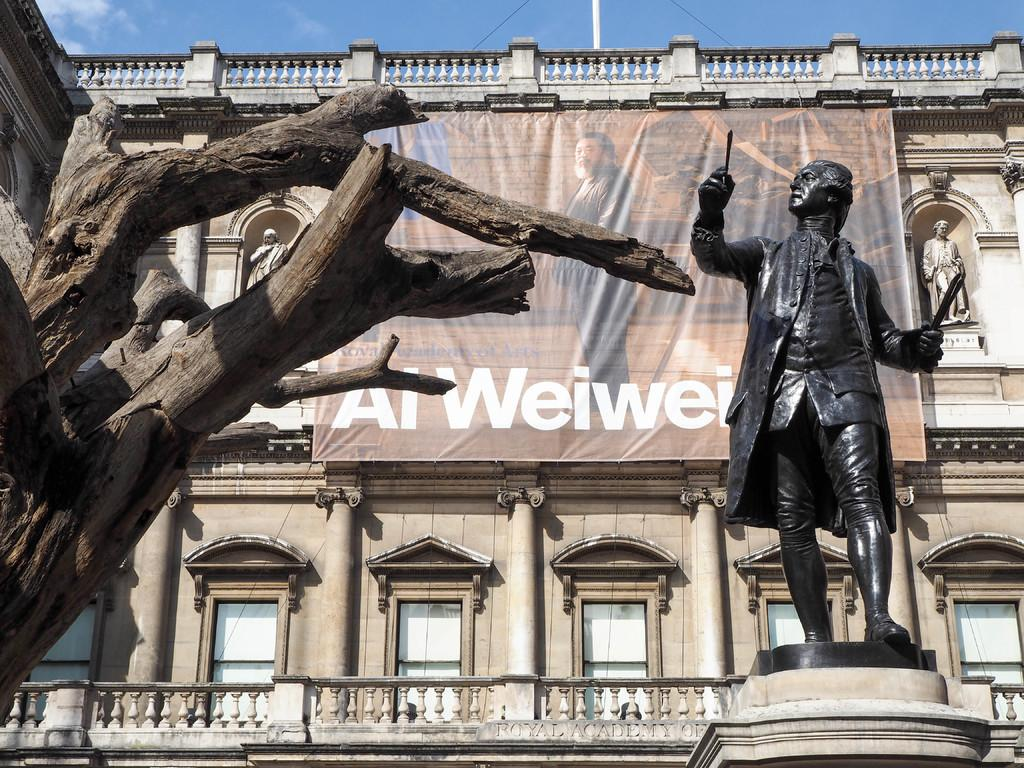<image>
Share a concise interpretation of the image provided. Al Weiwei has very bold white font on the front red brock fascia, which helps add contrast to the surroundings. 